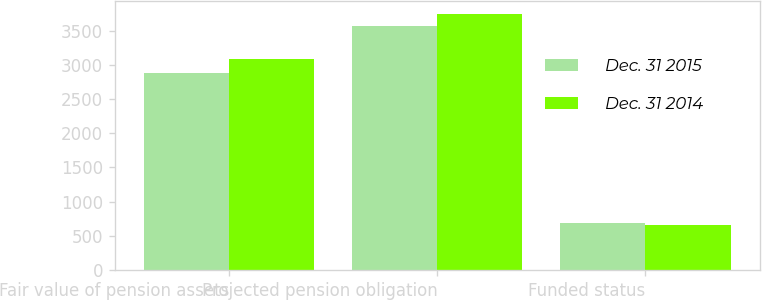Convert chart. <chart><loc_0><loc_0><loc_500><loc_500><stacked_bar_chart><ecel><fcel>Fair value of pension assets<fcel>Projected pension obligation<fcel>Funded status<nl><fcel>Dec. 31 2015<fcel>2884<fcel>3568<fcel>684<nl><fcel>Dec. 31 2014<fcel>3084<fcel>3747<fcel>663<nl></chart> 